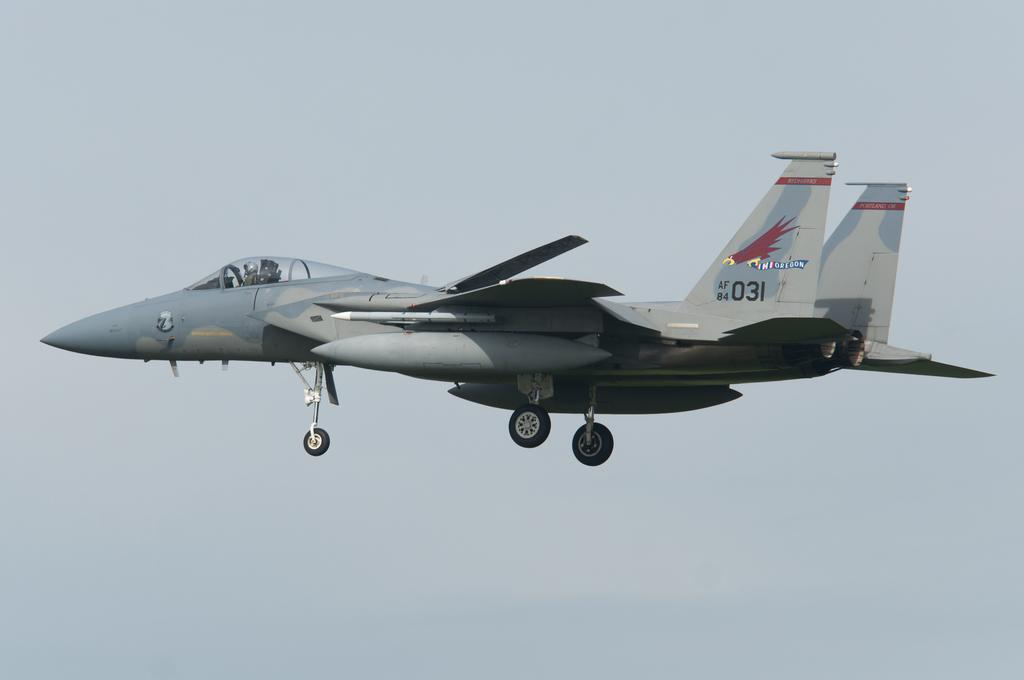<image>
Give a short and clear explanation of the subsequent image. fighter jet with eagle carrying oregon banner on tail and id AF 84 031 